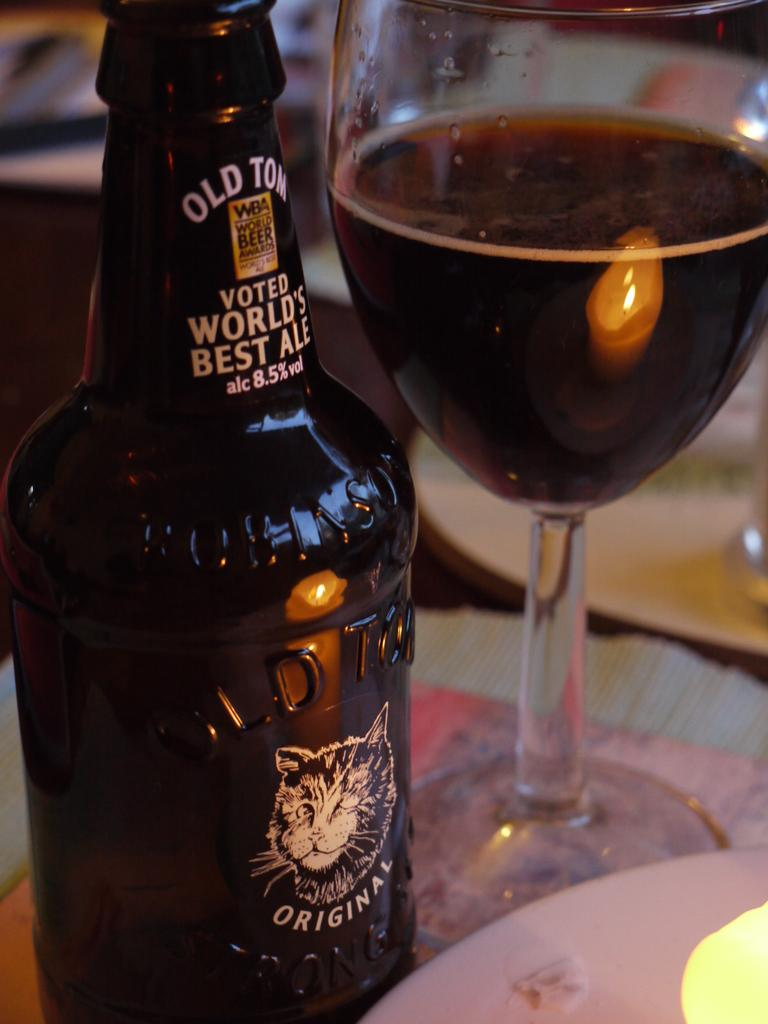Provide a one-sentence caption for the provided image. Old Tom voted World's Best Ale beer bottle with half glass of beer next to bottle. 